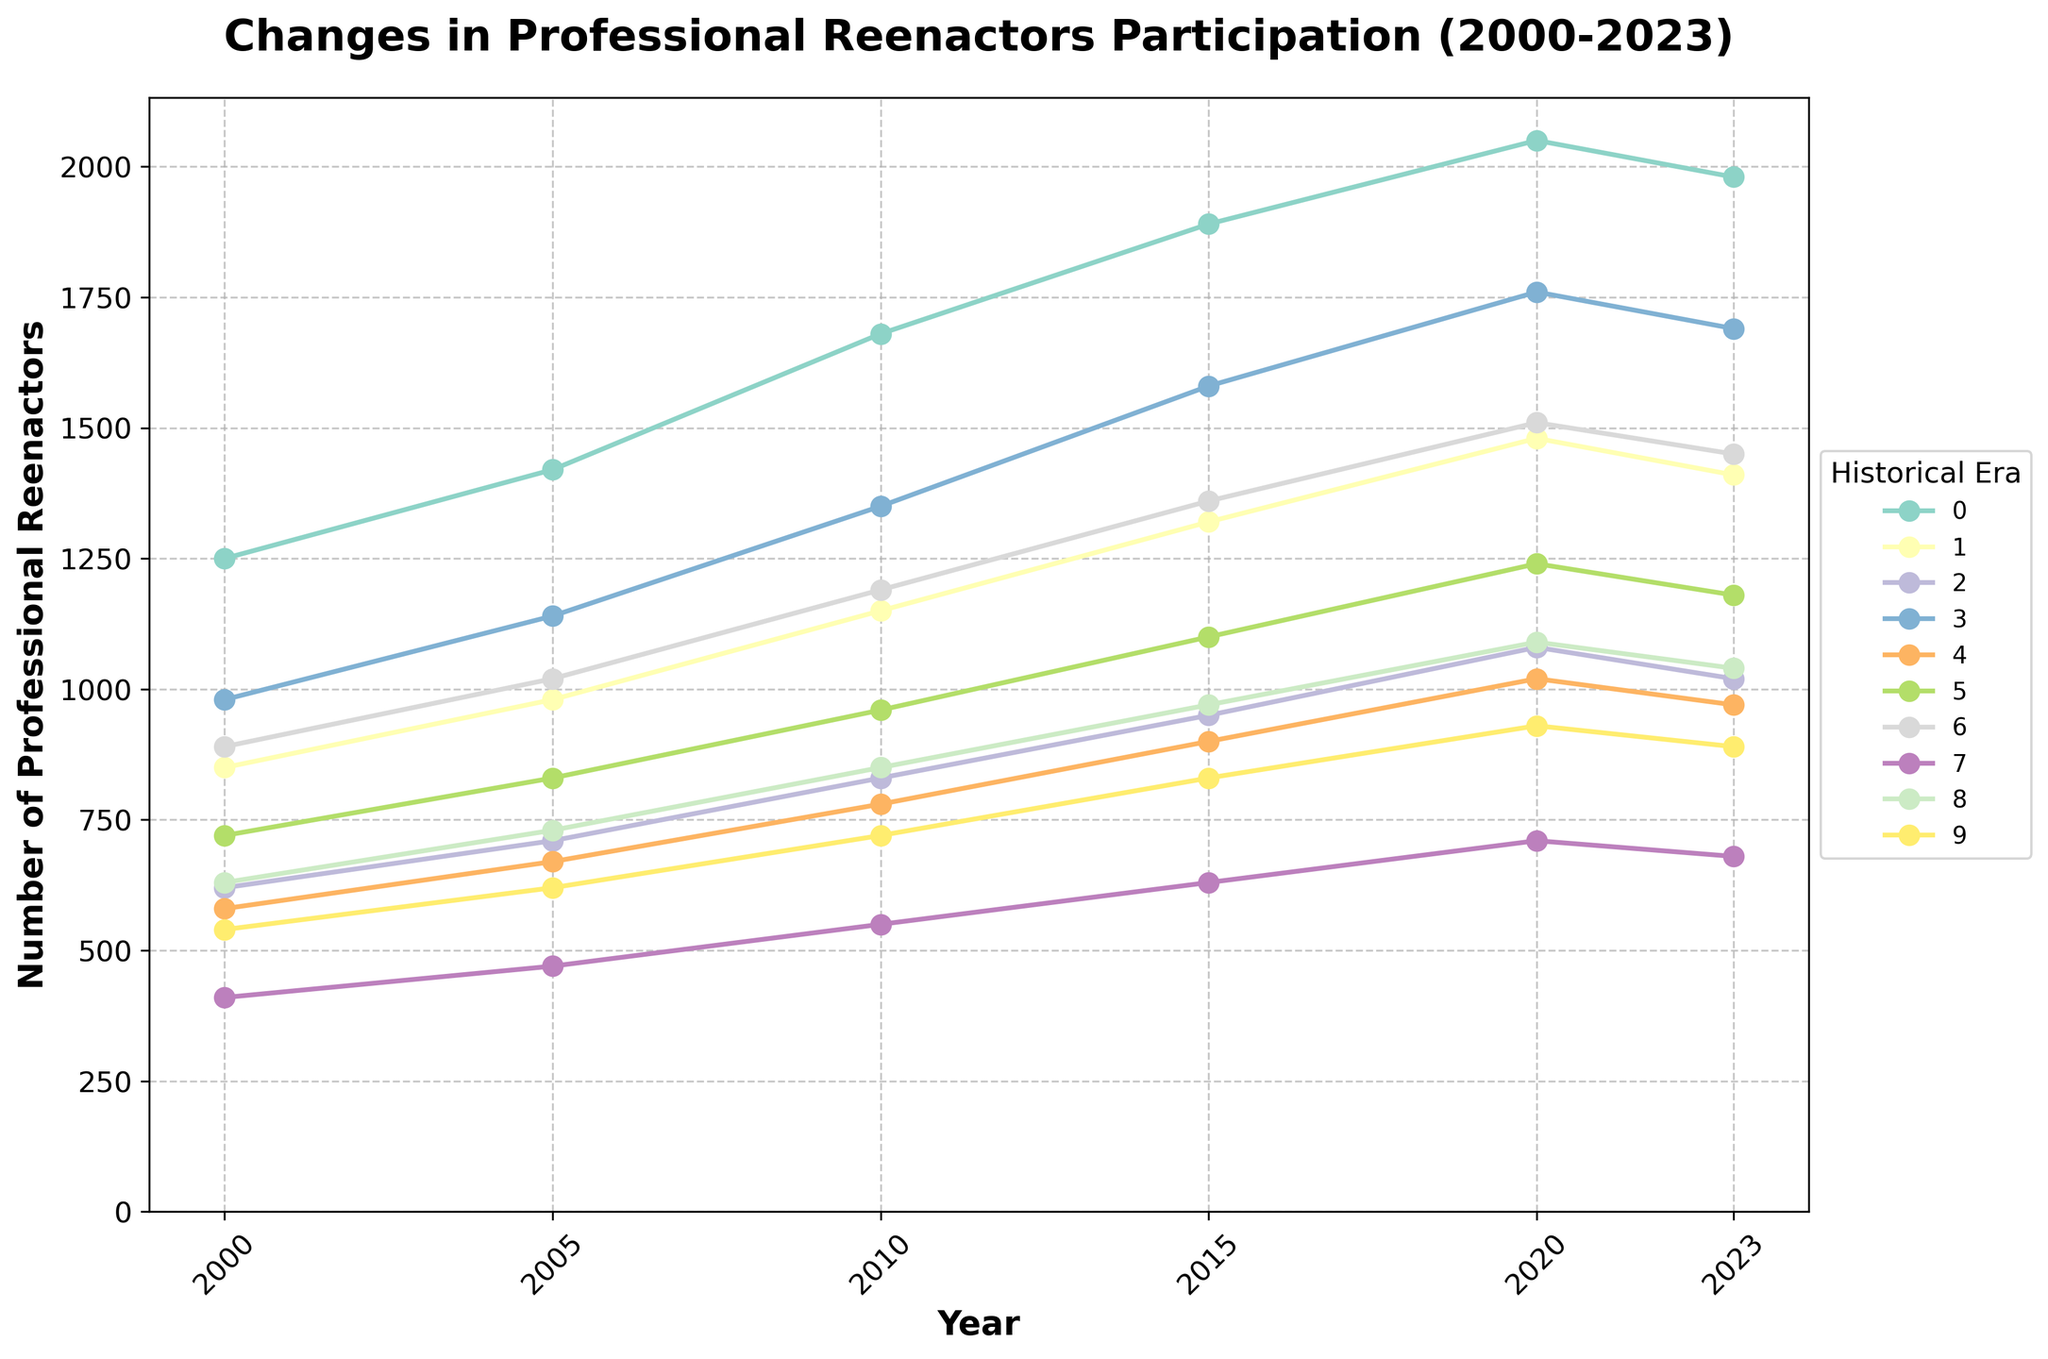What historical era saw the highest number of professional reenactors in 2023? To determine the era with the highest number of reenactors in 2023, look at the final data points for each era and identify the one with the maximum value. The "American Civil War" era has the highest value of 1980 in 2023.
Answer: American Civil War Which historical era experienced the greatest increase in the number of reenactors between 2000 and 2023? Calculate the difference between the values for 2000 and 2023 for each era. The era with the largest increase is the one with the highest value after subtraction. The "American Civil War" increased by 730 (1980-1250).
Answer: American Civil War Which two historical eras showed a decline in the number of professional reenactors from 2020 to 2023? Check the values for 2020 and 2023 for all eras and note where the number of reenactors has decreased. The "American Civil War" (2050 to 1980) and "Victorian Era" (1020 to 970) show declines.
Answer: American Civil War, Victorian Era What is the average number of reenactors for the "Renaissance" era across all years presented? Add the numbers for all specified years for the Renaissance era and divide by the number of years (6). (720 + 830 + 960 + 1100 + 1240 + 1180) / 6 = 1005.
Answer: 1005 For which historical era is the trend line almost flat, indicating the least change in the number of reenactors from 2000 to 2023? Look for the era with the smallest difference between its highest and lowest values over the period. The "Ancient Egypt" era ranges from 410 to 710, giving it the least change.
Answer: Ancient Egypt Which historical eras have shown a consistent upward trend without any drops in the number of reenactors from 2000 to 2023? Identify the eras whose values for each subsequent year are always greater than or equal to the previous year. No eras meet this criterion as they all have at least one fluctuation or drop.
Answer: None How does the number of professional reenactors in "World War II" in 2023 compare to that in 2000? Look at the values for "World War II" in 2000 and 2023 and subtract to find the increase. 1690 - 980 = 710 more reenactors in 2023.
Answer: 710 more What is the total number of professional reenactors for all historical eras combined in 2015? Sum the 2015 values for all eras. 1890 + 1320 + 950 + 1580 + 900 + 1100 + 1360 + 630 + 970 + 830 = 11530.
Answer: 11530 Which era had the highest percentage increase in reenactors from 2000 to 2023? For each era, calculate the percentage increase using (value in 2023 - value in 2000) / value in 2000 * 100. The "Victorian Era" has the highest percentage increase of about 67.24% (970 - 580) / 580 * 100.
Answer: Victorian Era What was the participation change from 2010 to 2020 in the "Wild West" era? Subtract the number in 2010 from the number in 2020 for the "Wild West" era. 1090 - 850 = 240.
Answer: 240 